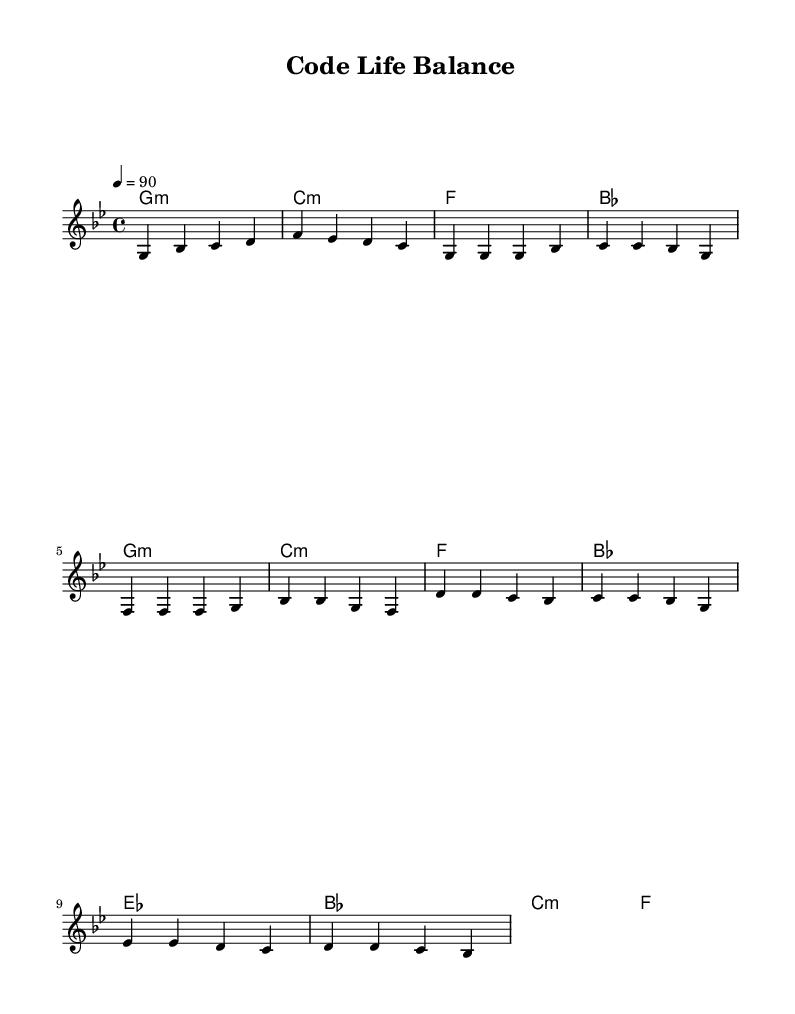What is the key signature of this music? The key signature is indicated by the number of flats or sharps in the beginning of the staff. In this case, there are two flats, which correspond to G minor.
Answer: G minor What is the time signature of this music? The time signature is indicated at the beginning of the staff, showing how many beats are in each measure (top number) and what note value gets the beat (bottom number). This music has a four beats per measure with quarter notes getting the beat.
Answer: 4/4 What is the tempo marking for this piece? The tempo marking is shown in beats per minute, indicated in the score. Here, the marking indicates a tempo of 90 beats per minute.
Answer: 90 How many measures are in the verse section? The verse section consists of a series of measures within the score. Counting the measures that are specifically marked as the verse, there are four measures.
Answer: 4 What chord is played in the first measure? The first measure of the score indicates the chord being played. The chord symbol 'G minor' appears, showing that this chord is played in the first measure.
Answer: G minor How does the chorus differ from the verse in terms of progression? The chorus incorporates different chord changes compared to the verse, particularly shifting from E flat to B flat then to C minor, indicating a change in harmony that typically marks the climax of the song. The variations in chord types create a different emotional response, common in hip-hop tracks.
Answer: E flat, B flat, C minor What thematic element does the lyrics focus on in this piece? Thematically, this hip-hop piece focuses on the challenges of work-life balance in the tech industry, discussing the tension between work demands and personal life, a common issue in modern tech culture.
Answer: Work-life balance 